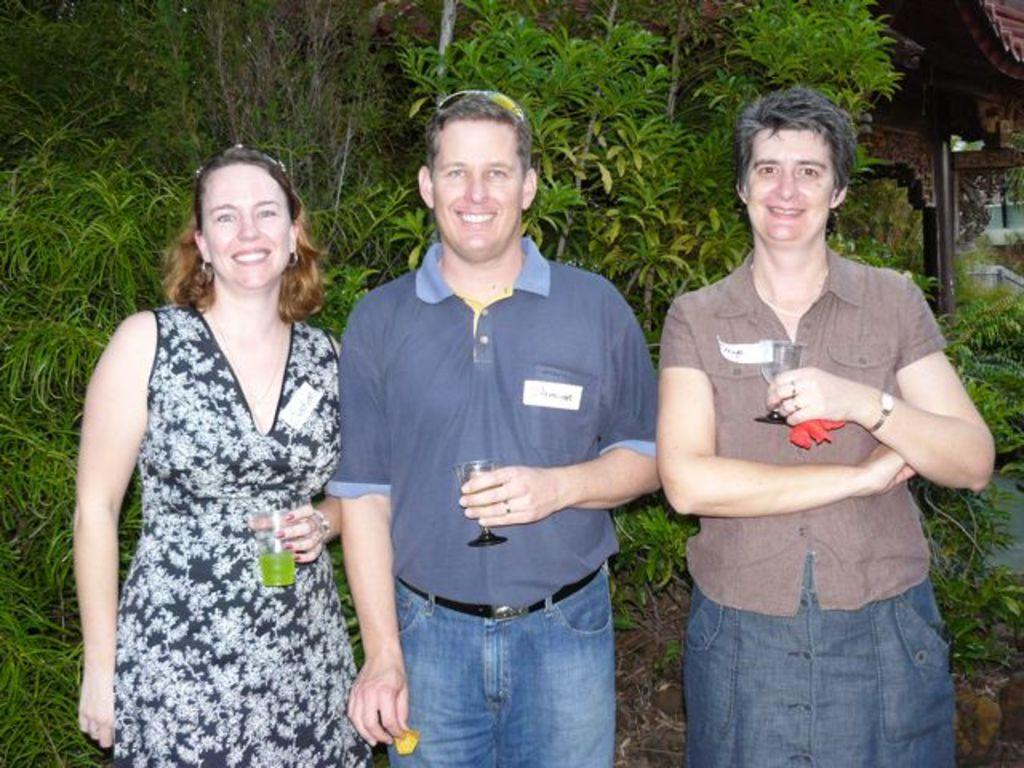How many people are present in the image? There are three people in the image. What are the people holding in their hands? The people are holding glasses and other objects in their hands. What can be seen in the background of the image? There is a pole, plants, and a building in the background of the image. What type of glove is the grandmother wearing in the image? There is no grandmother or glove present in the image. 